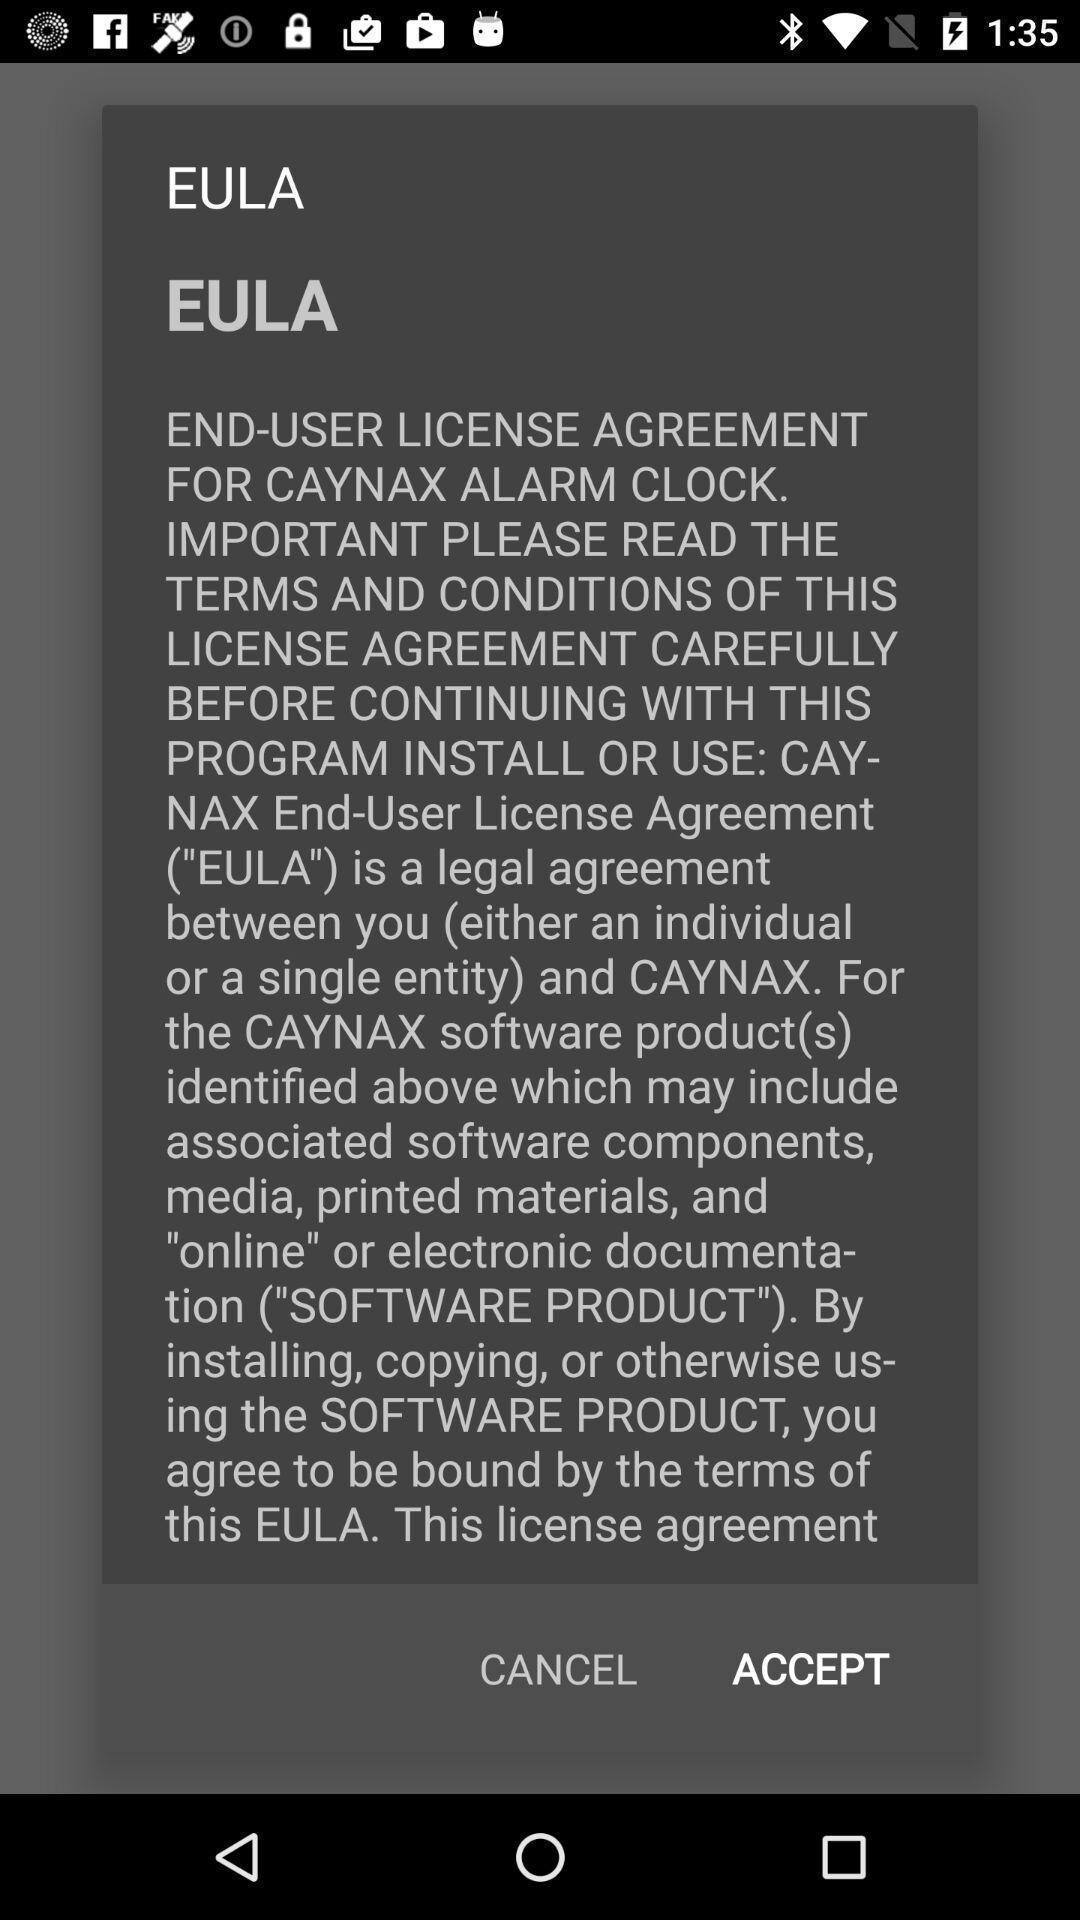Explain what's happening in this screen capture. Pop-up to accept the license agreement. 